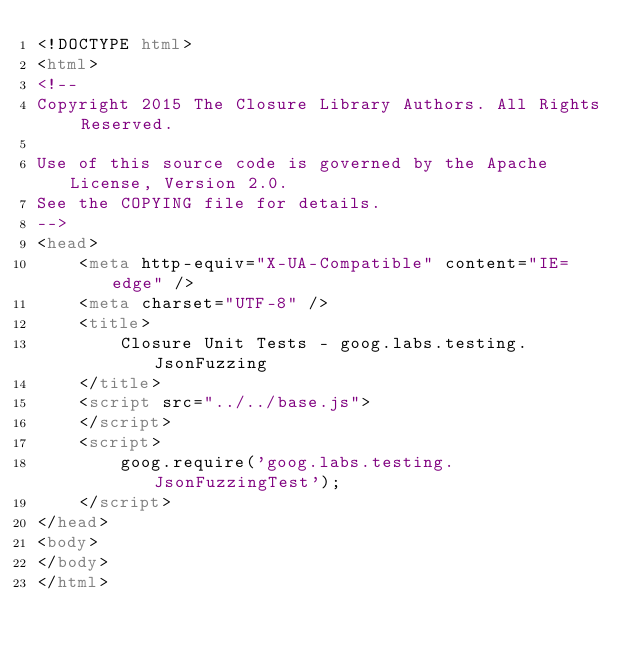Convert code to text. <code><loc_0><loc_0><loc_500><loc_500><_HTML_><!DOCTYPE html>
<html>
<!--
Copyright 2015 The Closure Library Authors. All Rights Reserved.

Use of this source code is governed by the Apache License, Version 2.0.
See the COPYING file for details.
-->
<head>
    <meta http-equiv="X-UA-Compatible" content="IE=edge" />
    <meta charset="UTF-8" />
    <title>
        Closure Unit Tests - goog.labs.testing.JsonFuzzing
    </title>
    <script src="../../base.js">
    </script>
    <script>
        goog.require('goog.labs.testing.JsonFuzzingTest');
    </script>
</head>
<body>
</body>
</html>
</code> 